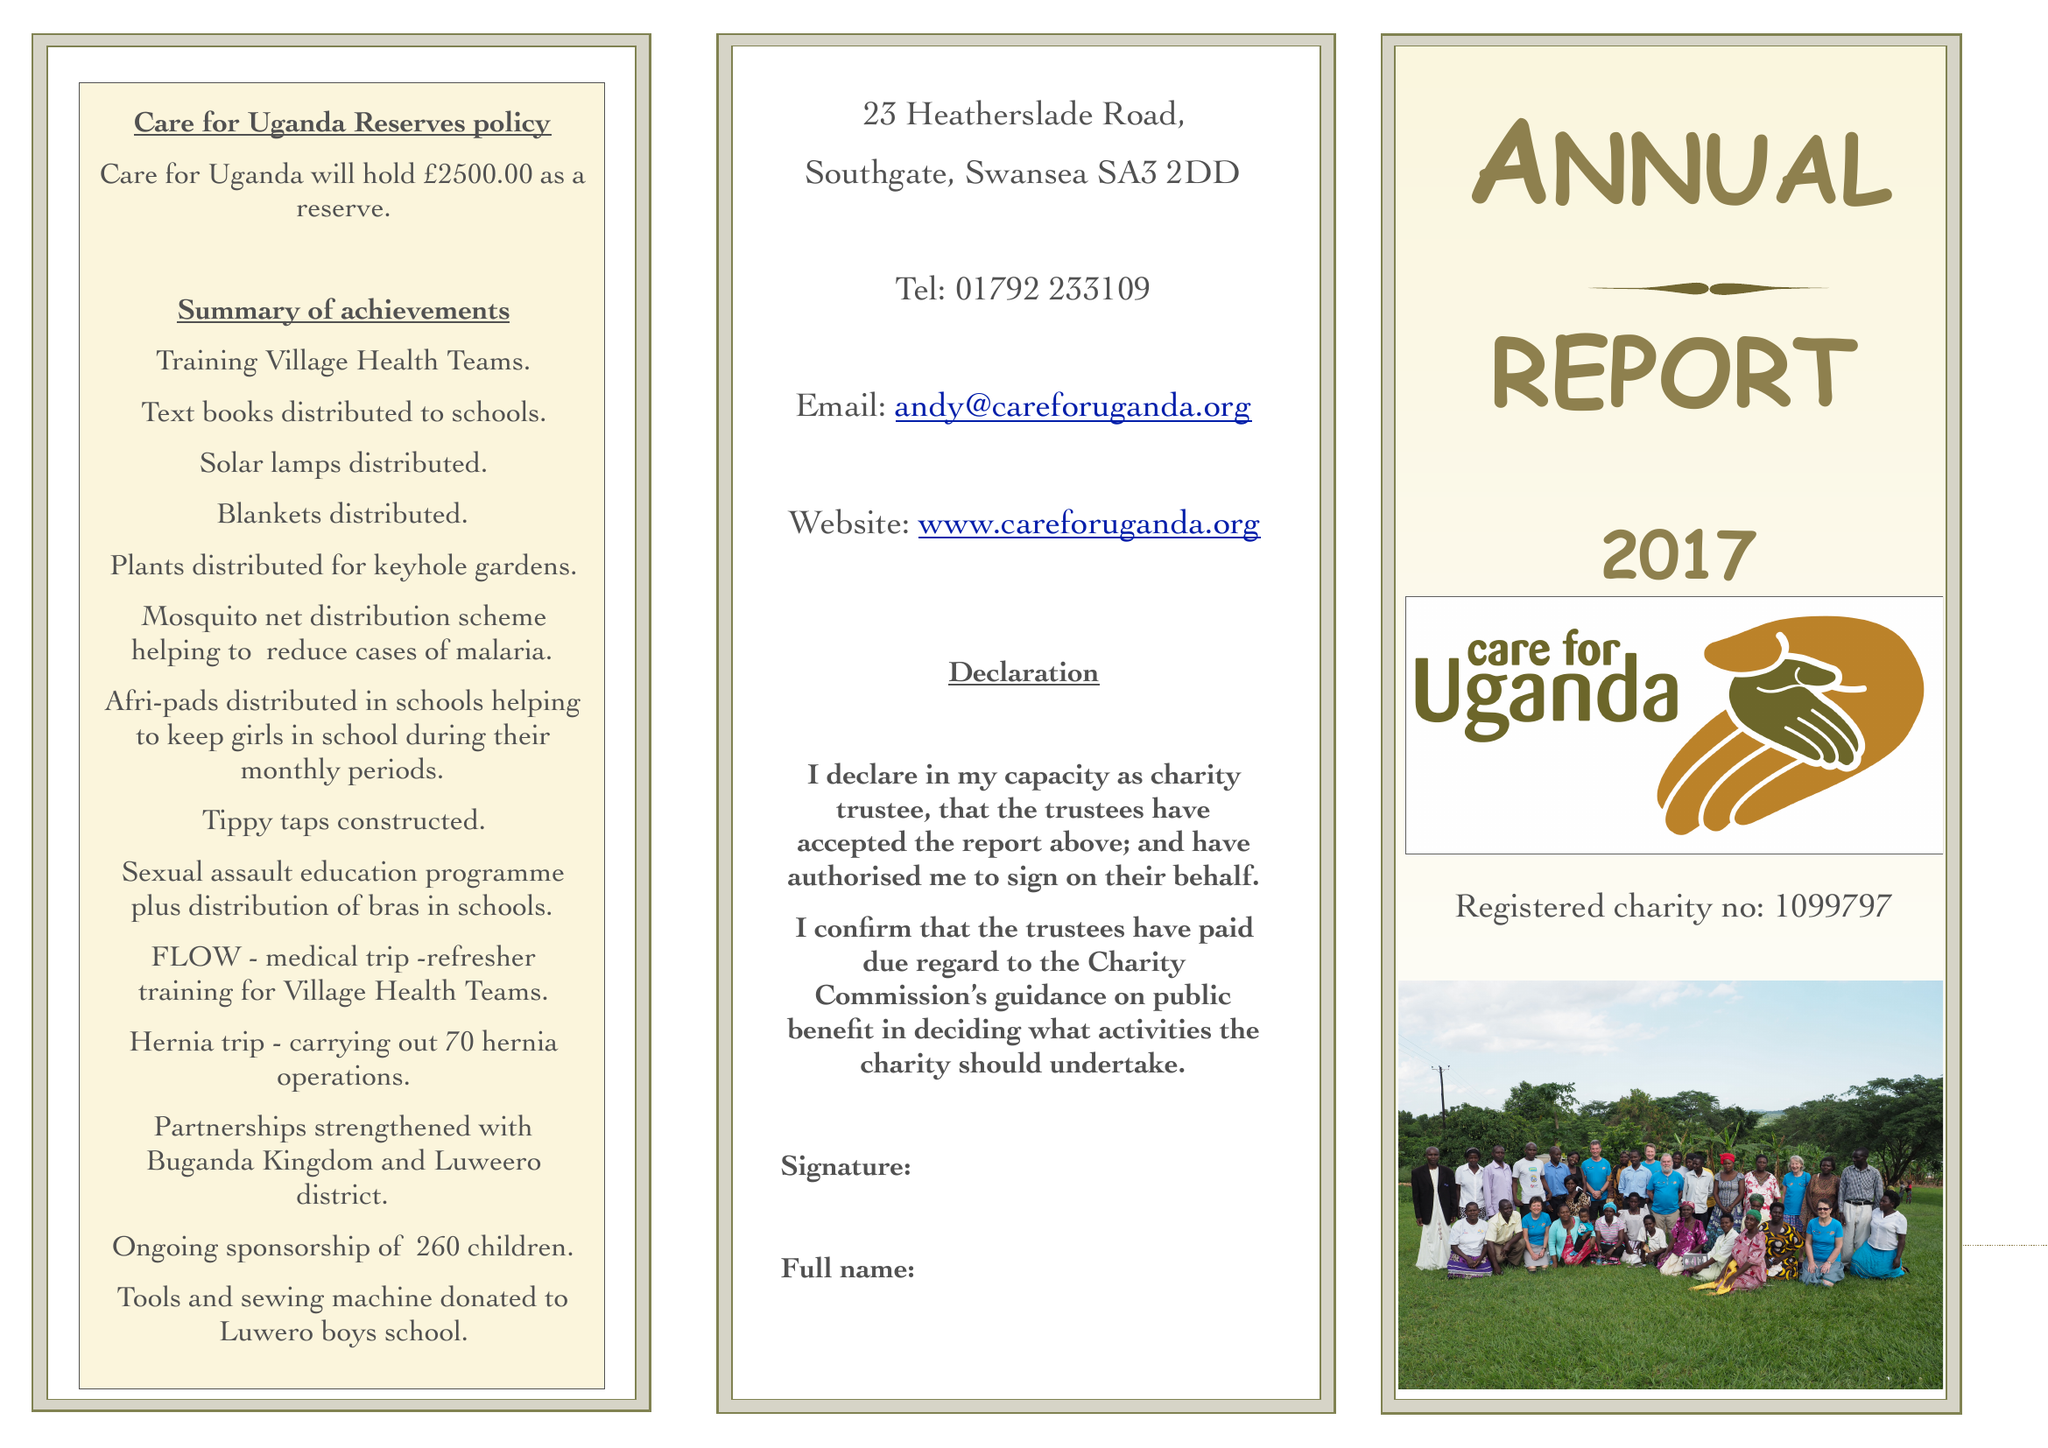What is the value for the charity_number?
Answer the question using a single word or phrase. 1099797 